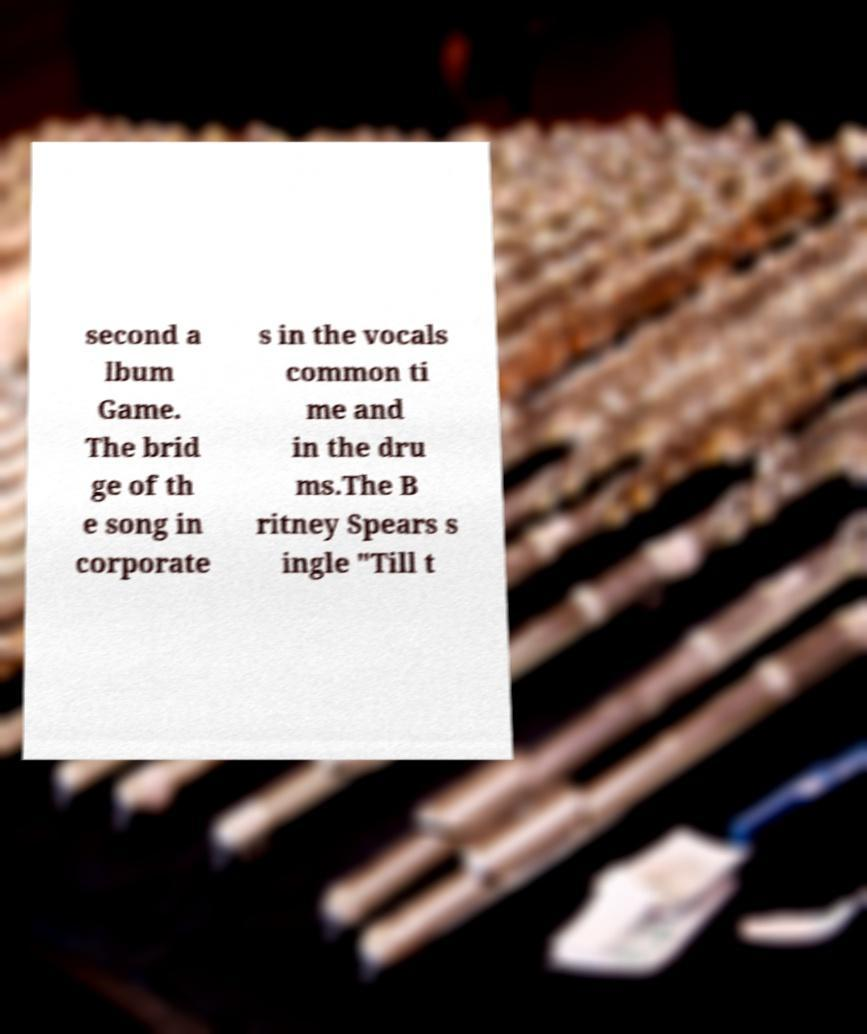Could you extract and type out the text from this image? second a lbum Game. The brid ge of th e song in corporate s in the vocals common ti me and in the dru ms.The B ritney Spears s ingle "Till t 